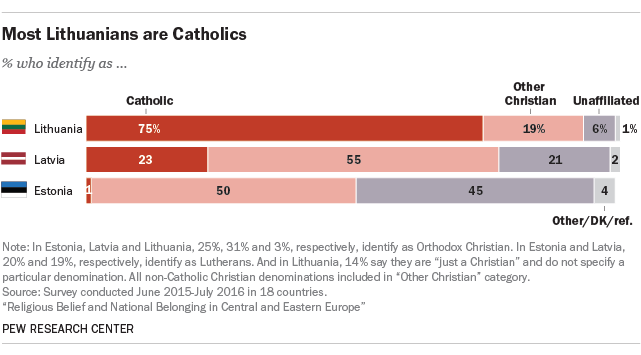Specify some key components in this picture. According to recent estimates, approximately 1% of the population in Estonia identifies as Catholic. The sum of Catholic and Other Christian in Estonia is 51. 